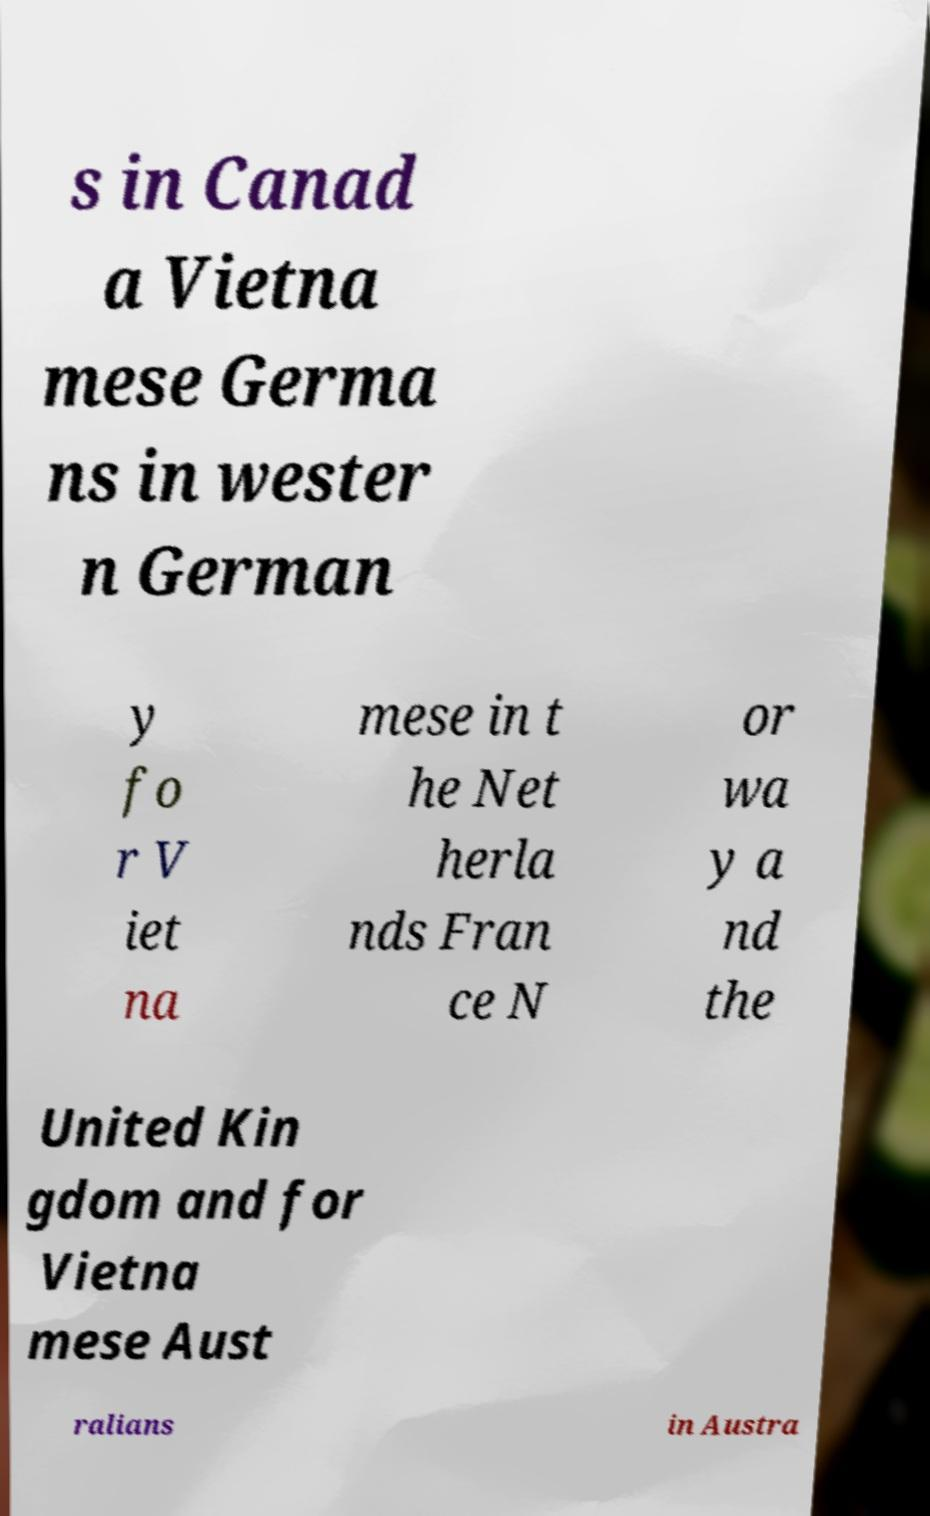Can you accurately transcribe the text from the provided image for me? s in Canad a Vietna mese Germa ns in wester n German y fo r V iet na mese in t he Net herla nds Fran ce N or wa y a nd the United Kin gdom and for Vietna mese Aust ralians in Austra 